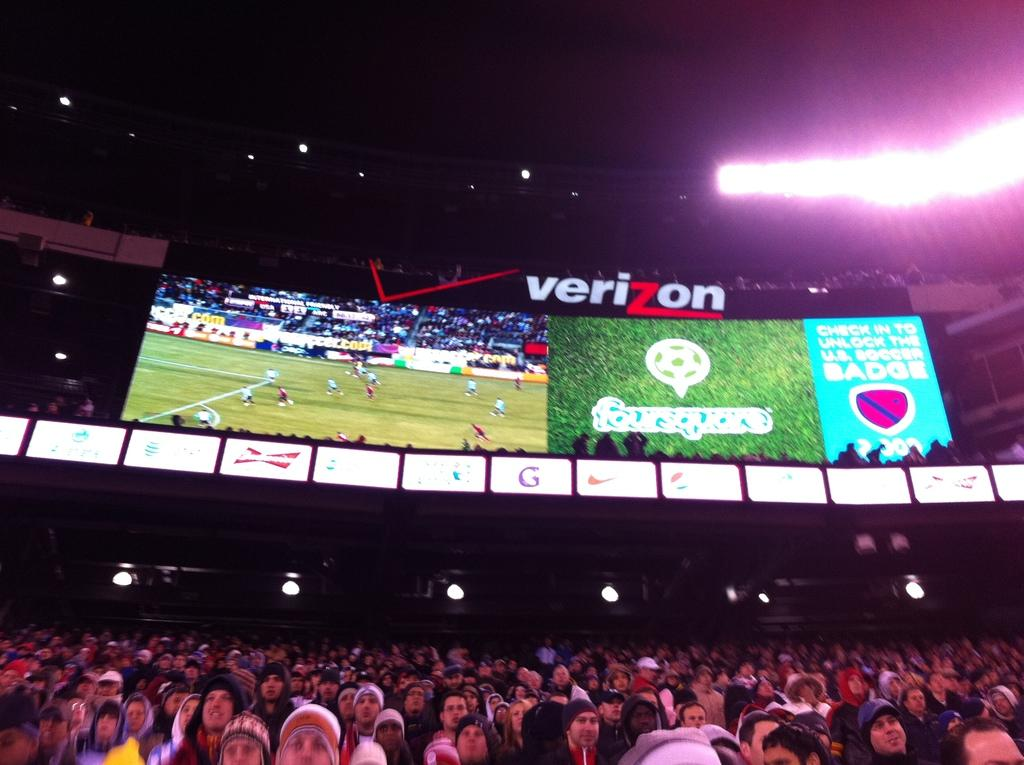<image>
Summarize the visual content of the image. A massive screen sposored by Verizon shows what is happening on the field at a soccer game as thousands of supporters watch the match. 